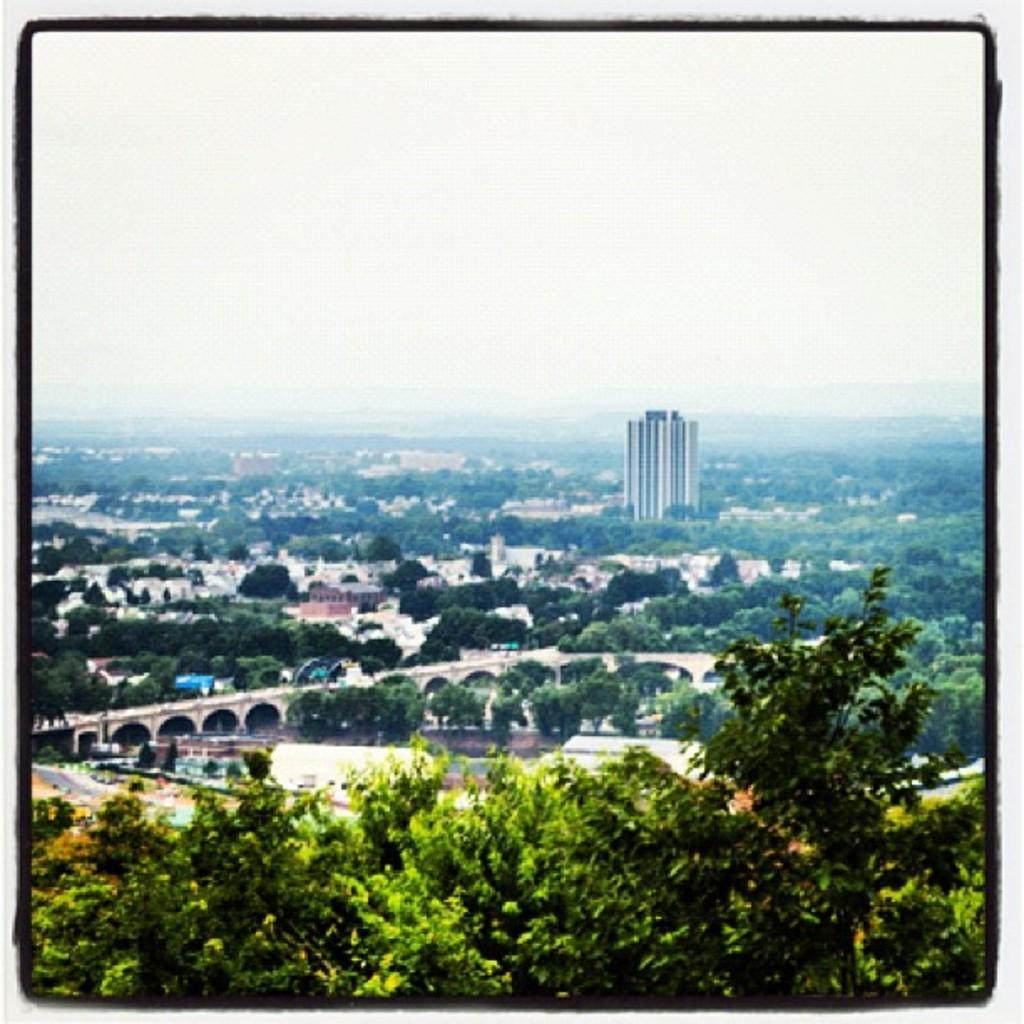Can you describe this image briefly? In this image we can see many trees, buildings, road and also bridge. We can also see the sky and the image has borders. 